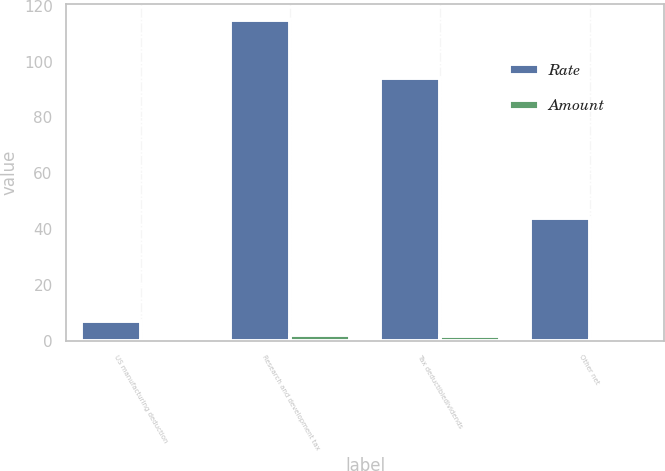Convert chart to OTSL. <chart><loc_0><loc_0><loc_500><loc_500><stacked_bar_chart><ecel><fcel>US manufacturing deduction<fcel>Research and development tax<fcel>Tax deductibledividends<fcel>Other net<nl><fcel>Rate<fcel>7<fcel>115<fcel>94<fcel>44<nl><fcel>Amount<fcel>0.1<fcel>2.2<fcel>1.8<fcel>0.8<nl></chart> 